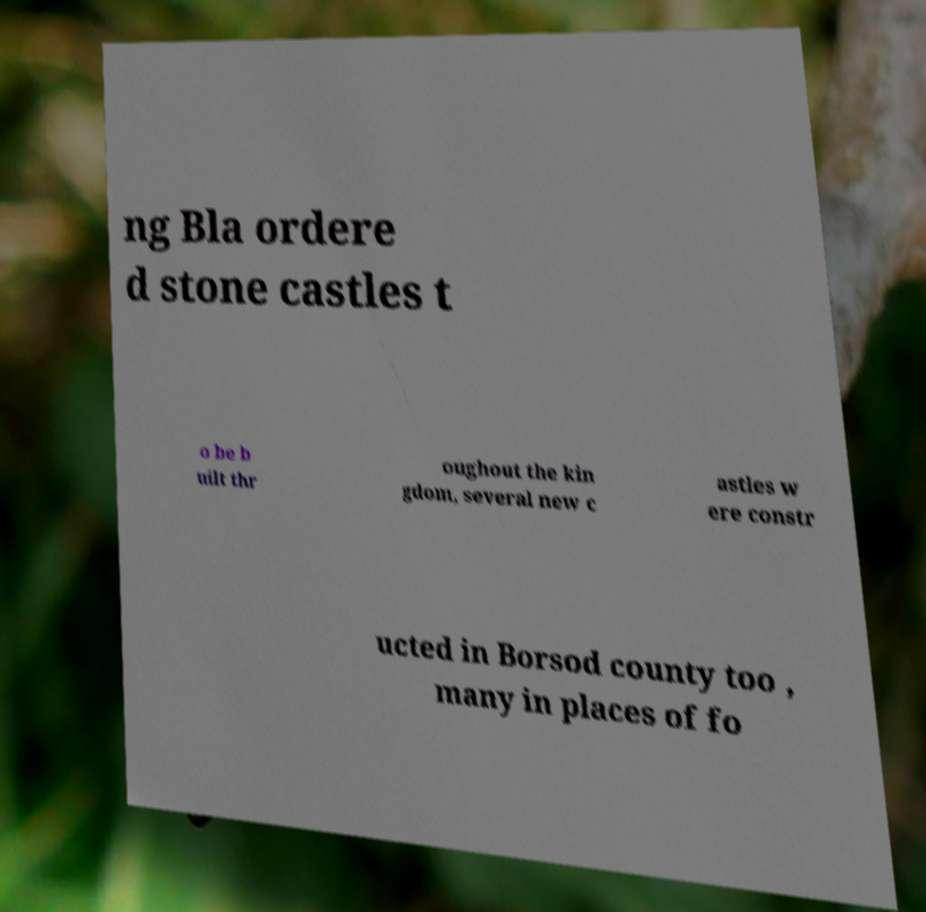Please read and relay the text visible in this image. What does it say? ng Bla ordere d stone castles t o be b uilt thr oughout the kin gdom, several new c astles w ere constr ucted in Borsod county too , many in places of fo 